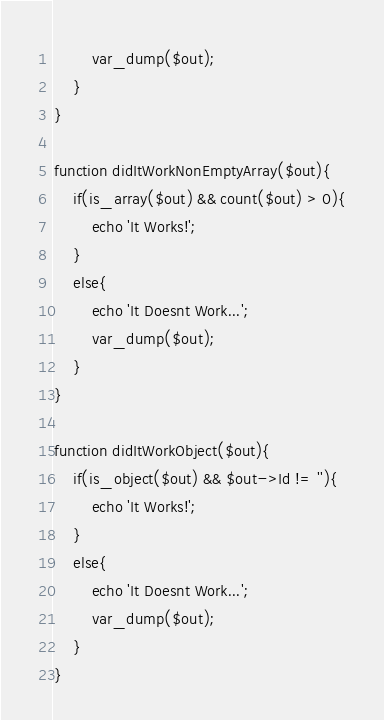Convert code to text. <code><loc_0><loc_0><loc_500><loc_500><_PHP_>		var_dump($out);
	}
}

function didItWorkNonEmptyArray($out){
	if(is_array($out) && count($out) > 0){
		echo 'It Works!';
	}
	else{
		echo 'It Doesnt Work...';
		var_dump($out);
	}
}

function didItWorkObject($out){
	if(is_object($out) && $out->Id != ''){
		echo 'It Works!';
	}
	else{
		echo 'It Doesnt Work...';
		var_dump($out);
	}
}
</code> 